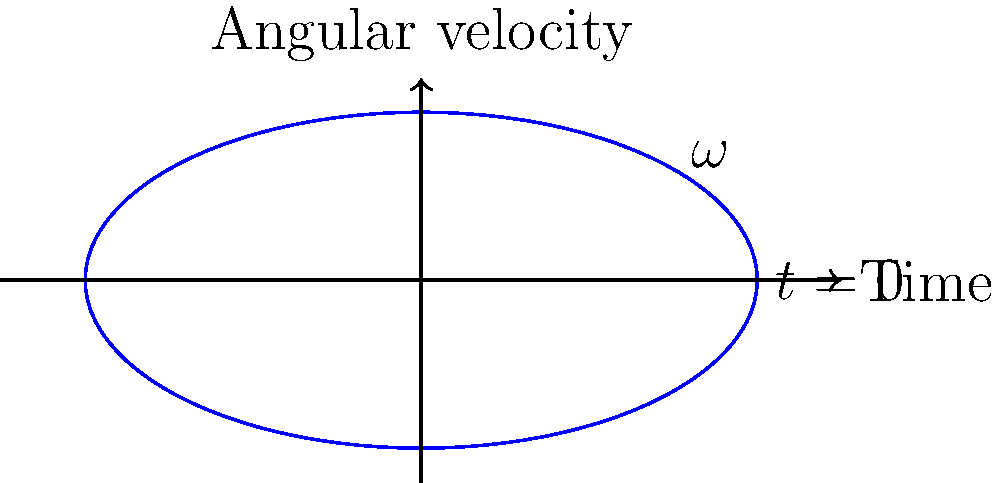A discus thrower's arm motion is analyzed, and the angular velocity ($\omega$) of the arm is plotted against time as shown in the graph. The motion follows a sinusoidal pattern described by the equation $\omega(t) = 20 \sin(t)$ rad/s, where $t$ is in seconds. What is the maximum angular acceleration experienced by the thrower's arm during this motion? To find the maximum angular acceleration, we need to follow these steps:

1) The angular velocity is given by $\omega(t) = 20 \sin(t)$ rad/s.

2) The angular acceleration is the derivative of angular velocity with respect to time:
   
   $\alpha(t) = \frac{d\omega}{dt} = \frac{d}{dt}(20 \sin(t)) = 20 \cos(t)$ rad/s²

3) The maximum value of cosine is 1, which occurs when its argument is 0, π, 2π, etc.

4) Therefore, the maximum angular acceleration is:
   
   $\alpha_{max} = 20 \cdot 1 = 20$ rad/s²

This occurs when $\cos(t) = 1$, i.e., at $t = 0$, $2\pi$, $4\pi$, etc., which correspond to the points where the angular velocity is zero and changing most rapidly.
Answer: 20 rad/s² 